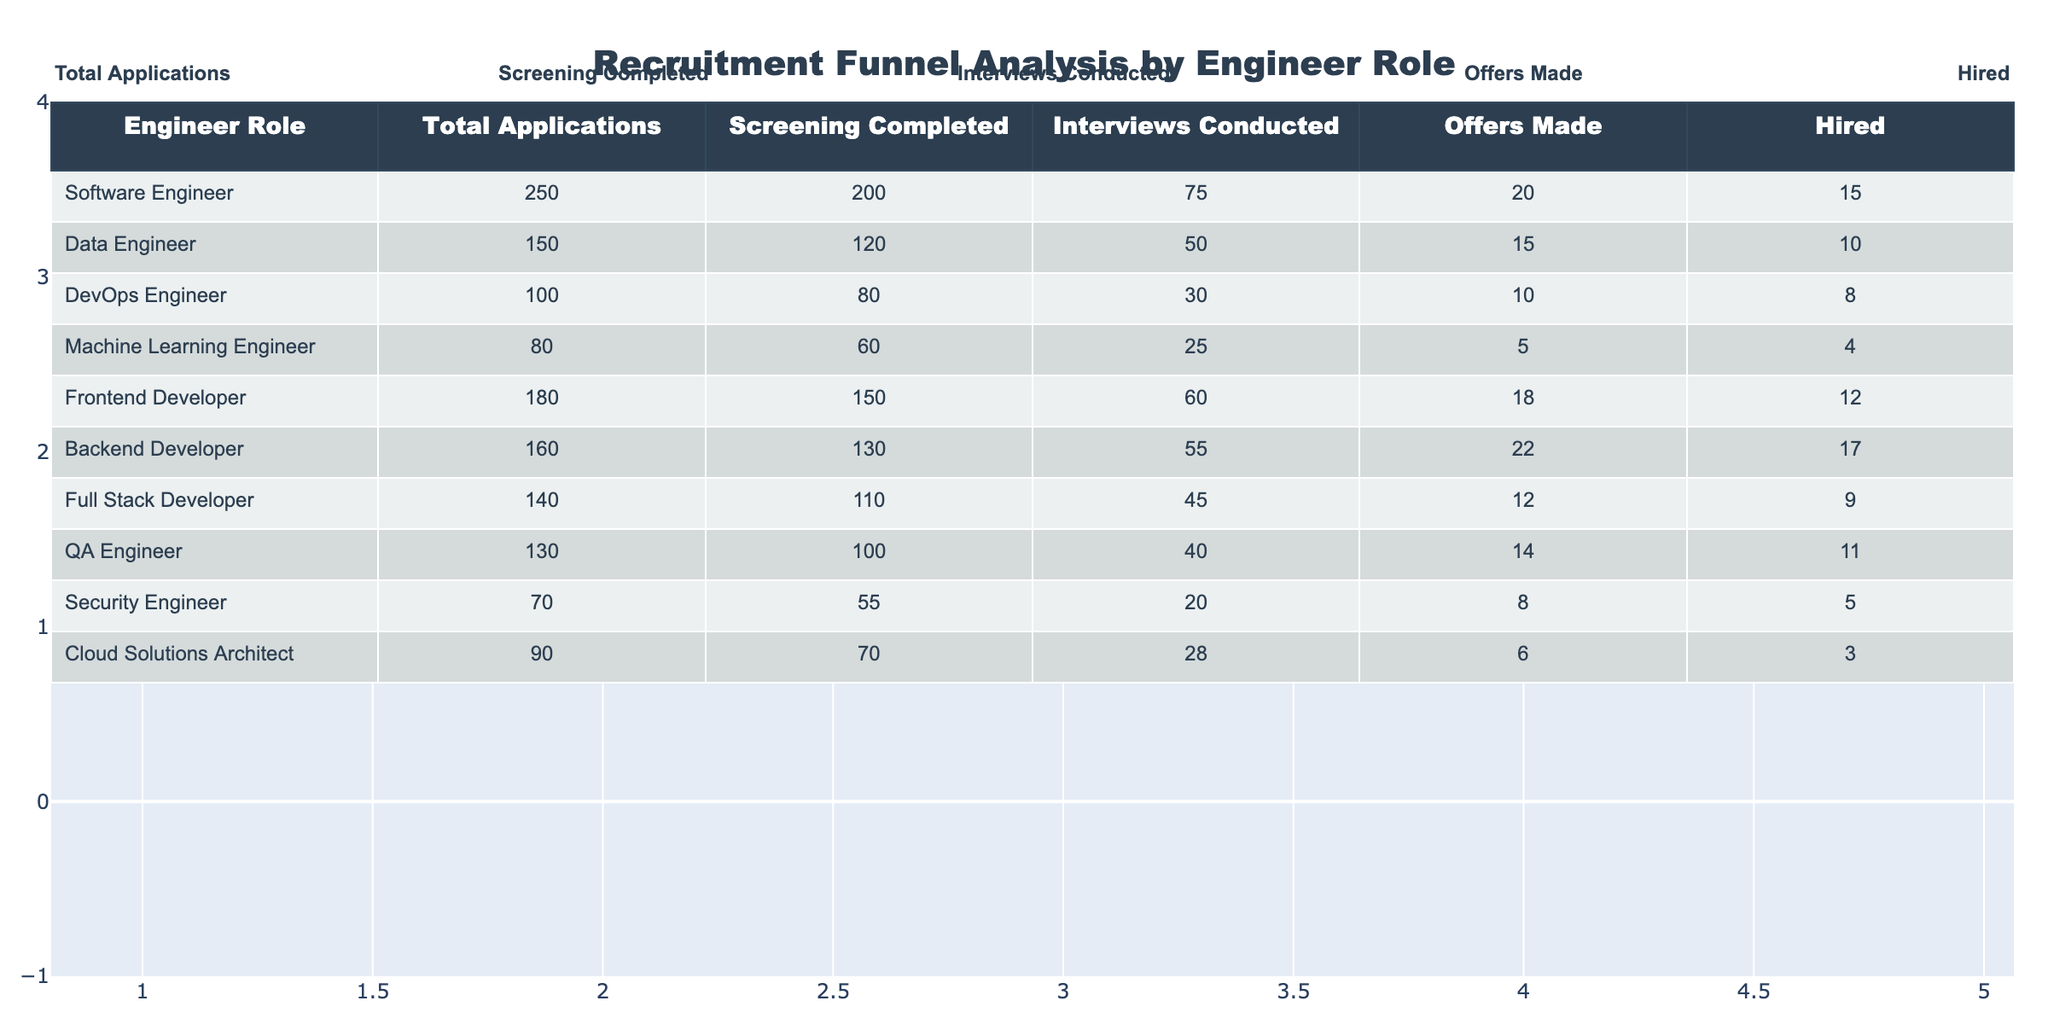What is the total number of applications for the Software Engineer role? The table shows that the total applications for the Software Engineer role is listed directly under the "Total Applications" column for that role. Looking at the table, it states 250 applications.
Answer: 250 How many hires were made for the Data Engineer role? Referring to the "Hired" column for the Data Engineer role in the table, it states that 10 hires were made.
Answer: 10 What is the difference in the number of offers made between the Frontend Developer and Backend Developer roles? We look at the "Offers Made" column. For the Frontend Developer, there were 18 offers made, and for the Backend Developer, there were 22 offers made. The difference is 22 - 18 = 4.
Answer: 4 Which engineer role had the highest ratio of offers made to total applications? First, we calculate the ratio of offers made to total applications for each role. For example, Software Engineer has a ratio of 20/250, Data Engineer has 15/150, and so on. The highest ratio is for the Data Engineer with 0.1 (10%) since 15/150 equals 0.1. Thus, the Data Engineer role has the highest ratio.
Answer: Data Engineer Is it true that the Cloud Solutions Architect had more screening completions than the Machine Learning Engineer? Looking at the "Screening Completed" column, we see that the Cloud Solutions Architect has 70 and the Machine Learning Engineer has 60. Since 70 is greater than 60, the statement is true.
Answer: Yes What is the average number of interviews conducted across all roles? To find the average, we sum the "Interviews Conducted" for all roles: 75 + 50 + 30 + 25 + 60 + 55 + 45 + 40 + 20 + 28 =  438. There are 10 roles, so the average is 438 divided by 10, which gives us 43.8.
Answer: 43.8 Did more offers get made in total for the Quality Assurance Engineer than for Machine Learning Engineer? Checking the "Offers Made" column, QA Engineer has 14 offers, whereas Machine Learning Engineer has 5 offers. Since 14 is greater than 5, the statement is true.
Answer: Yes Which role has the lowest total applications? Looking at the "Total Applications" column, we can see that the Machine Learning Engineer has the lowest number, with 80 total applications.
Answer: Machine Learning Engineer How many more applications did the Software Engineer receive than the Cloud Solutions Architect? From the "Total Applications" column, we see Software Engineer has 250 applications, and Cloud Solutions Architect has 90 applications. The difference is 250 - 90 = 160.
Answer: 160 